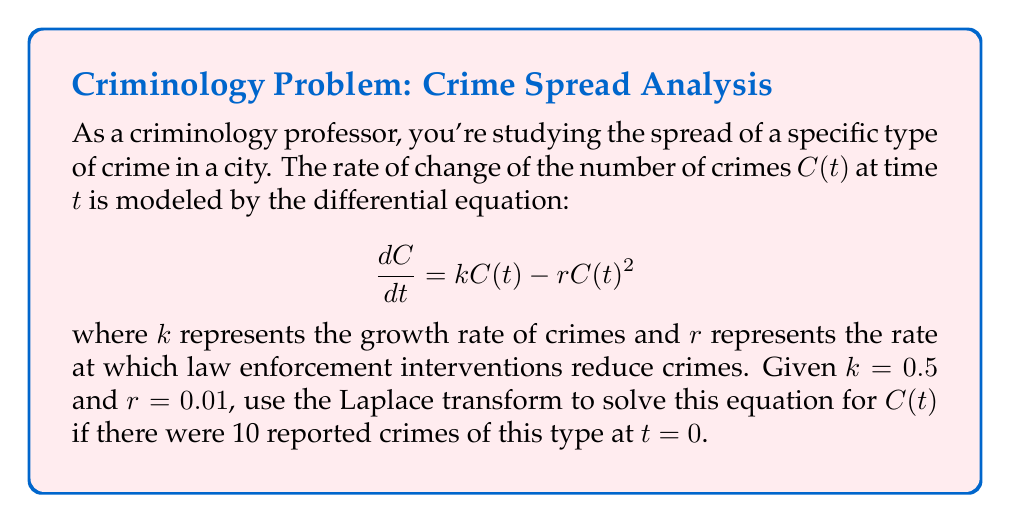Give your solution to this math problem. Let's solve this step-by-step using Laplace transforms:

1) First, let's take the Laplace transform of both sides of the equation:

   $\mathcal{L}\{\frac{dC}{dt}\} = \mathcal{L}\{kC(t) - rC(t)^2\}$

2) Using the linearity property and the Laplace transform of the derivative:

   $sC(s) - C(0) = k\mathcal{L}\{C(t)\} - r\mathcal{L}\{C(t)^2\}$

3) We know $C(0) = 10$, and $\mathcal{L}\{C(t)\} = C(s)$, but $\mathcal{L}\{C(t)^2\}$ is nonlinear and complicates the solution. We need to linearize the equation.

4) Let $y(t) = \frac{1}{C(t)}$. Then $\frac{dy}{dt} = -\frac{1}{C^2}\frac{dC}{dt}$

5) Substituting into the original equation:

   $-\frac{1}{y^2}\frac{dy}{dt} = k\frac{1}{y} - r$

6) Multiplying both sides by $-y^2$:

   $\frac{dy}{dt} = -ky + ry^2$

7) Now we can apply the Laplace transform:

   $sY(s) - Y(0) = -kY(s) + r\mathcal{L}\{y^2\}$

8) We know $Y(0) = \frac{1}{C(0)} = \frac{1}{10}$. Let's ignore the nonlinear term for now:

   $(s+k)Y(s) = \frac{1}{10}$

9) Solving for $Y(s)$:

   $Y(s) = \frac{1}{10(s+k)}$

10) Taking the inverse Laplace transform:

    $y(t) = \frac{1}{10}e^{-kt}$

11) Substituting back $C(t) = \frac{1}{y(t)}$:

    $C(t) = 10e^{kt}$

12) With $k = 0.5$, our final solution is:

    $C(t) = 10e^{0.5t}$

Note: This solution ignores the nonlinear term, which is an approximation valid for small $t$ or small $r$.
Answer: $C(t) = 10e^{0.5t}$ 